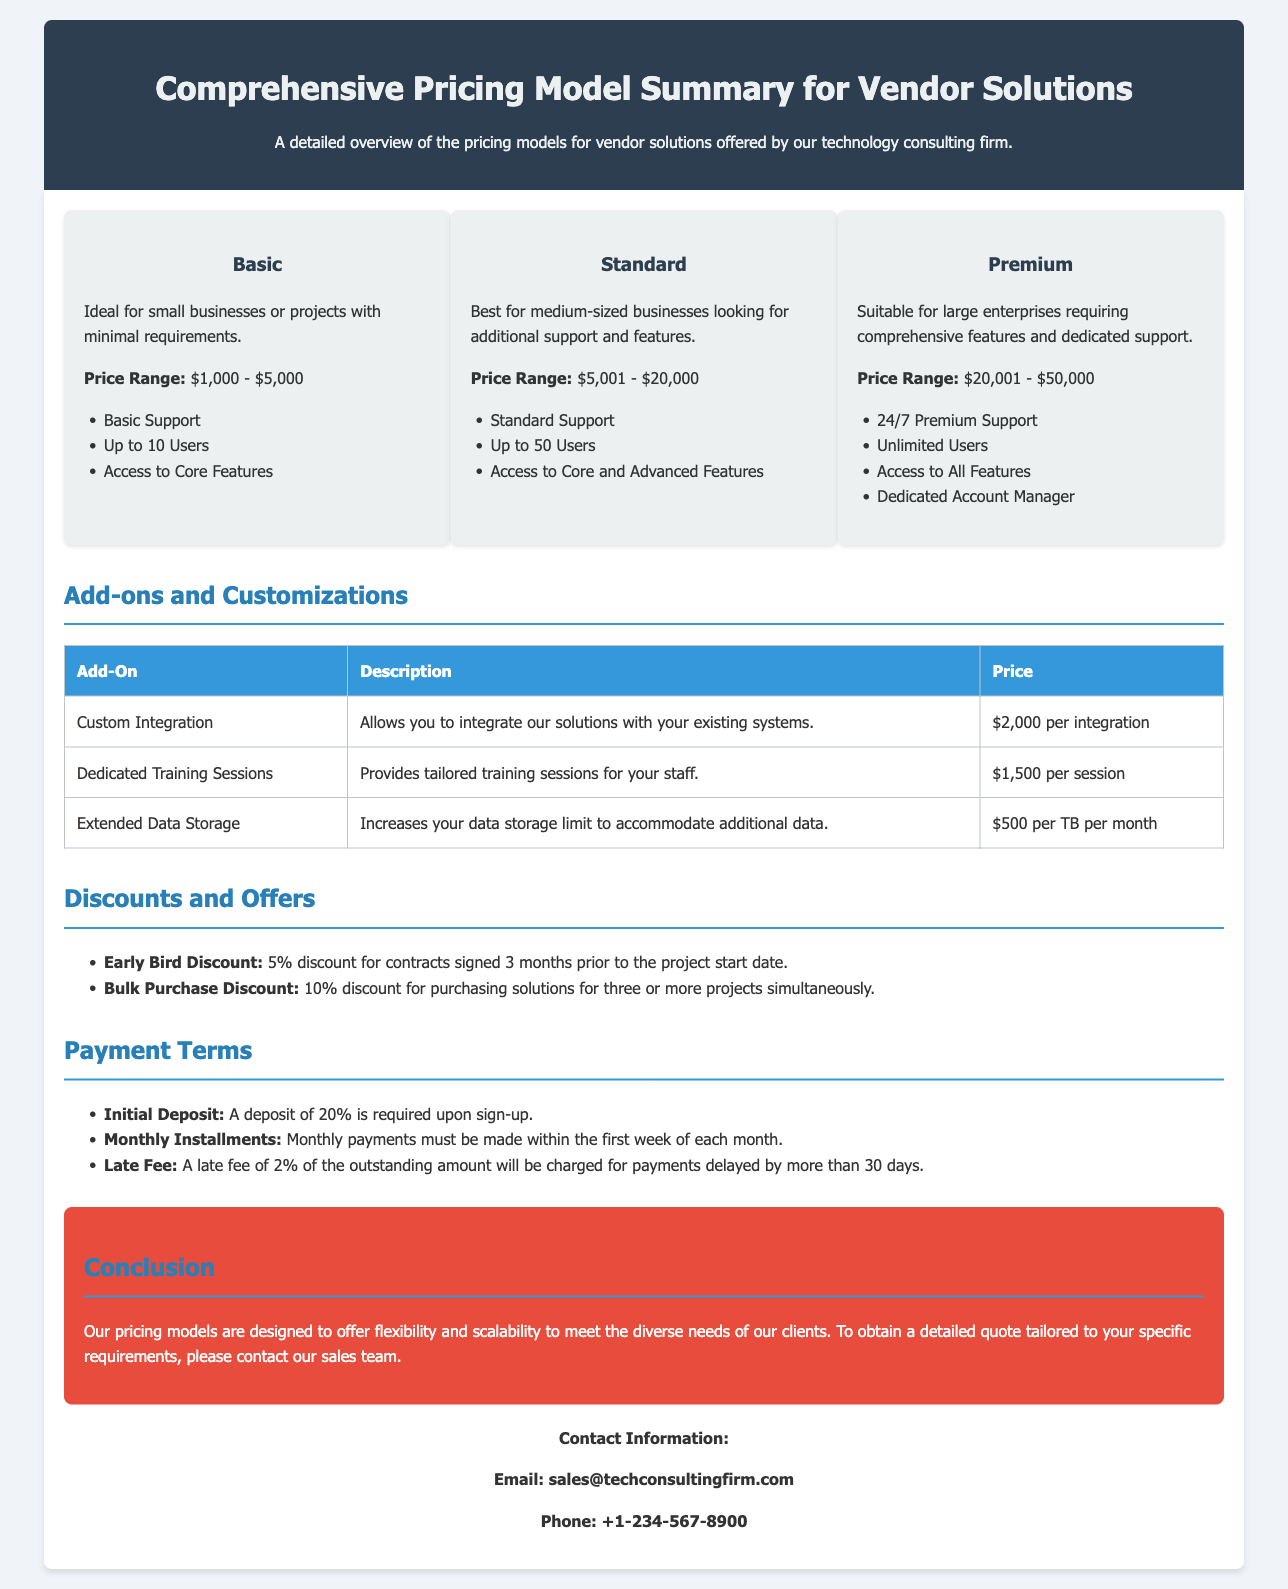what is the price range for the Basic tier? The price range for the Basic tier is provided in the document.
Answer: $1,000 - $5,000 what features are included in the Premium tier? The document lists the features included in the Premium tier.
Answer: 24/7 Premium Support, Unlimited Users, Access to All Features, Dedicated Account Manager how much is the Early Bird Discount? The Early Bird Discount amount is explicitly stated in the document.
Answer: 5% what is the initial deposit requirement? The document specifies the initial deposit amount required upon sign-up.
Answer: 20% what is the price for Custom Integration add-on? The price for the Custom Integration add-on is detailed in the table within the document.
Answer: $2,000 per integration how many users does the Standard tier support? The document specifies the user support included in the Standard tier.
Answer: Up to 50 Users what is the late fee for delayed payments? The late fee amount is mentioned in the payment terms section of the document.
Answer: 2% what types of companies is the Basic tier ideal for? The document describes the target audience for the Basic tier.
Answer: Small businesses or projects with minimal requirements what is offered to clients under the Bulk Purchase Discount? The document states the conditions for the Bulk Purchase Discount.
Answer: 10% discount for purchasing solutions for three or more projects simultaneously 